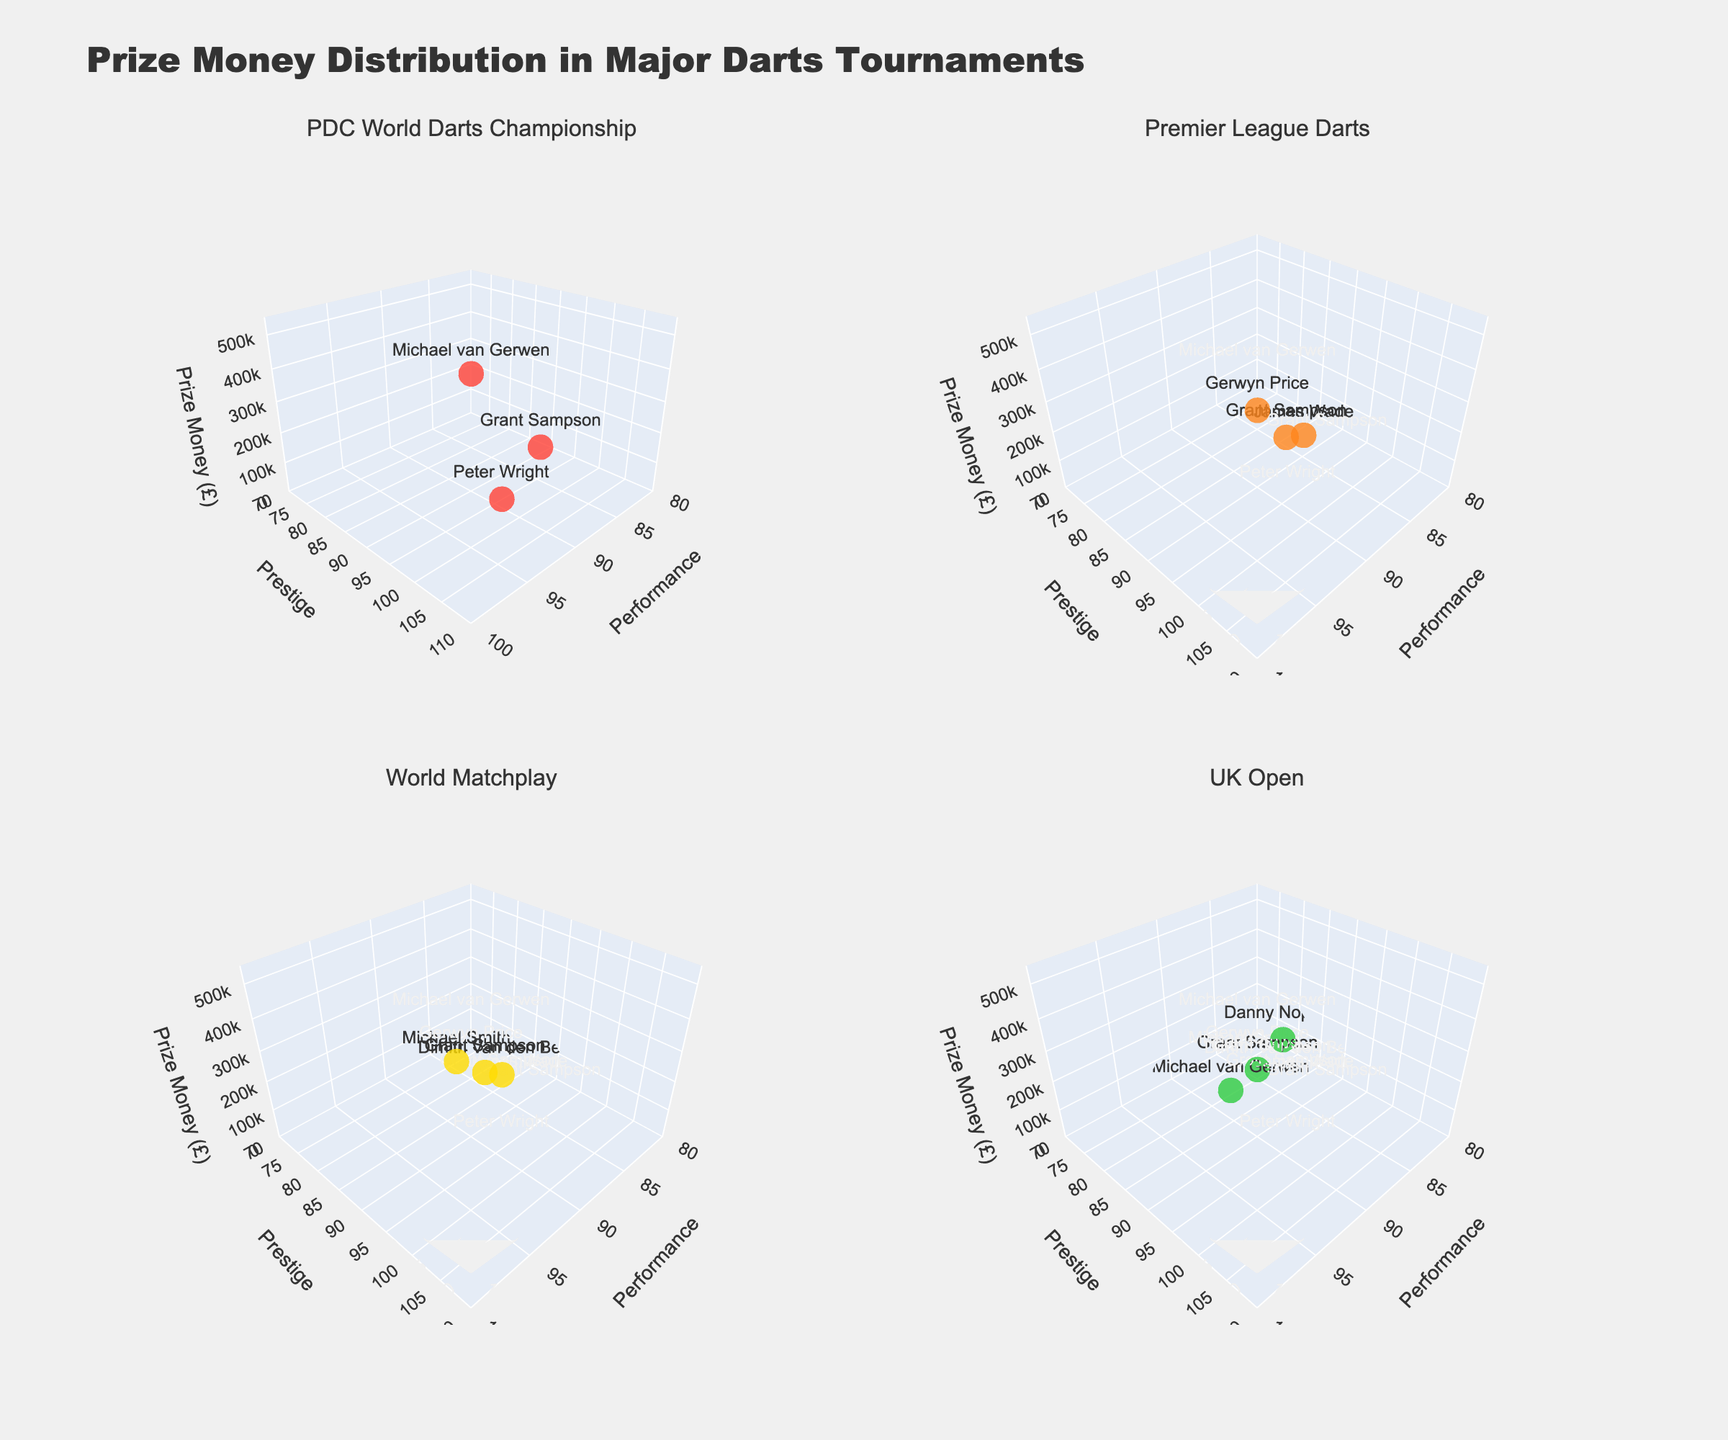What is the title of the figure? The title is usually prominently displayed at the top of the figure. By reading it, we can identify the overall subject of the plot.
Answer: Prize Money Distribution in Major Darts Tournaments What does the 'z' axis represent across all subplots? Each subplot will share common axis labels, and by examining any subplot, you can see that the 'z' axis consistently represents 'Prize Money (£)'.
Answer: Prize Money (£) Which player earned the highest prize money in the PDC World Darts Championship? In the subplot for the PDC World Darts Championship, the highest z-axis value corresponds to Michael van Gerwen with £500,000.
Answer: Michael van Gerwen How many players participated in the Premier League Darts tournament as shown in the figure? By counting the number of data points (markers) in the subplot for the Premier League Darts, you can determine the number of participants.
Answer: 3 Comparing Grant Sampson's performance in the World Matchplay and the UK Open, in which did he earn more prize money? By examining the subplots for the World Matchplay and UK Open, we compare the z-axis values for Grant Sampson: £100,000 in the World Matchplay and £40,000 in the UK Open.
Answer: World Matchplay What is the color used to represent the UK Open tournament in the figure? Each subplot is color-coded. The UK Open tournament uses '#FFDC00', which appears as a yellow color.
Answer: Yellow What is the total prize money earned by Grant Sampson across all tournaments shown? Summing up the prize money of Grant Sampson in each subplot: £200,000 (PDC World Darts Championship) + £120,000 (Premier League Darts) + £100,000 (World Matchplay) + £40,000 (UK Open) + £60,000 (European Championship).
Answer: £520,000 Are there any common locations for the tournaments shown in the subplots? If yes, which ones? By looking at the 'Location' column across different subplots, you'll see locations like 'Various UK Cities', 'London', etc. Checking for repetition among these names yields 'London' as a common location.
Answer: London Which subplot shows the tournament with the highest overall prestige rating? 'Prestige' is graphed on the y-axis. The PDC World Darts Championship has the highest prestige rating (100) for all its data points.
Answer: PDC World Darts Championship In the PDC World Darts Championship subplot, which player shows up as the second-highest in prize money and what is their performance score? By identifying the second-highest z-axis value (probably via hover information) and noting both the prize and the corresponding performance value, the player is Grant Sampson with a performance score of 88.
Answer: Grant Sampson, 88 